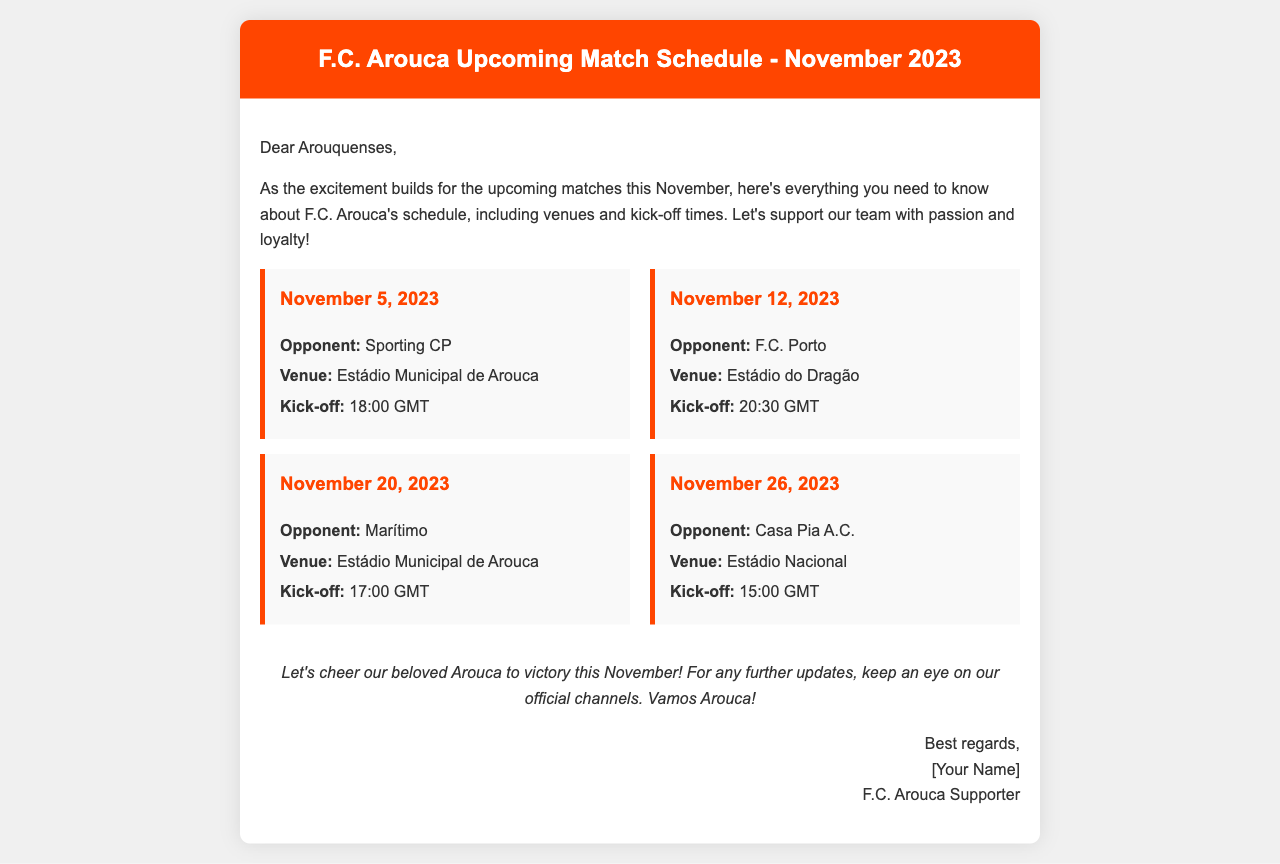What is the date of the match against Sporting CP? The match against Sporting CP is scheduled for November 5, 2023.
Answer: November 5, 2023 Where will F.C. Arouca play against F.C. Porto? The match against F.C. Porto will be held at Estádio do Dragão.
Answer: Estádio do Dragão What time is the kick-off for the match on November 20? The kick-off for the match on November 20, 2023, is at 17:00 GMT.
Answer: 17:00 GMT Who is the opponent for the match on November 26? The opponent for the match on November 26, 2023, is Casa Pia A.C.
Answer: Casa Pia A.C How many matches are scheduled in November 2023? The document lists four matches scheduled in November 2023.
Answer: Four matches What is the venue for the match against Marítimo? The match against Marítimo will take place at Estádio Municipal de Arouca.
Answer: Estádio Municipal de Arouca What is the main purpose of this document? The document provides information about the upcoming match schedule for F.C. Arouca in November 2023.
Answer: Upcoming match schedule What color is used for the header background in the document? The header background color is orange, specifically FF4500.
Answer: Orange 